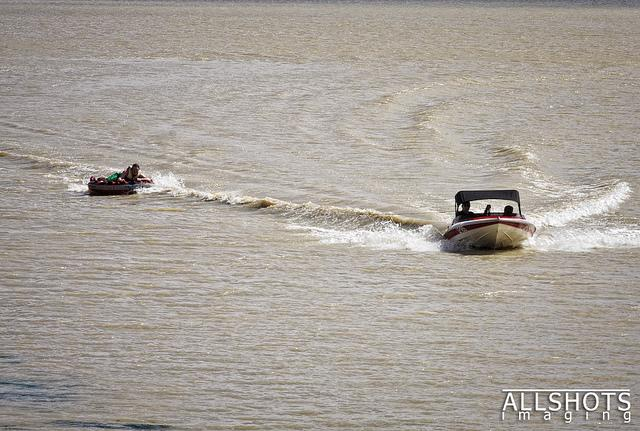How is the small vessel being moved?

Choices:
A) motor
B) sail
C) pushed
D) towed towed 